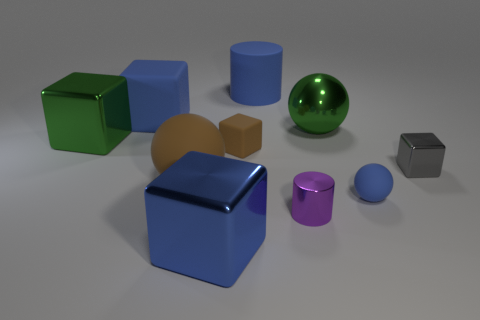There is a gray thing; is its shape the same as the blue object that is in front of the tiny ball? Yes, the shape of the gray object is indeed a cube, which matches the shape of the larger blue cube positioned in front of the small blue ball. 